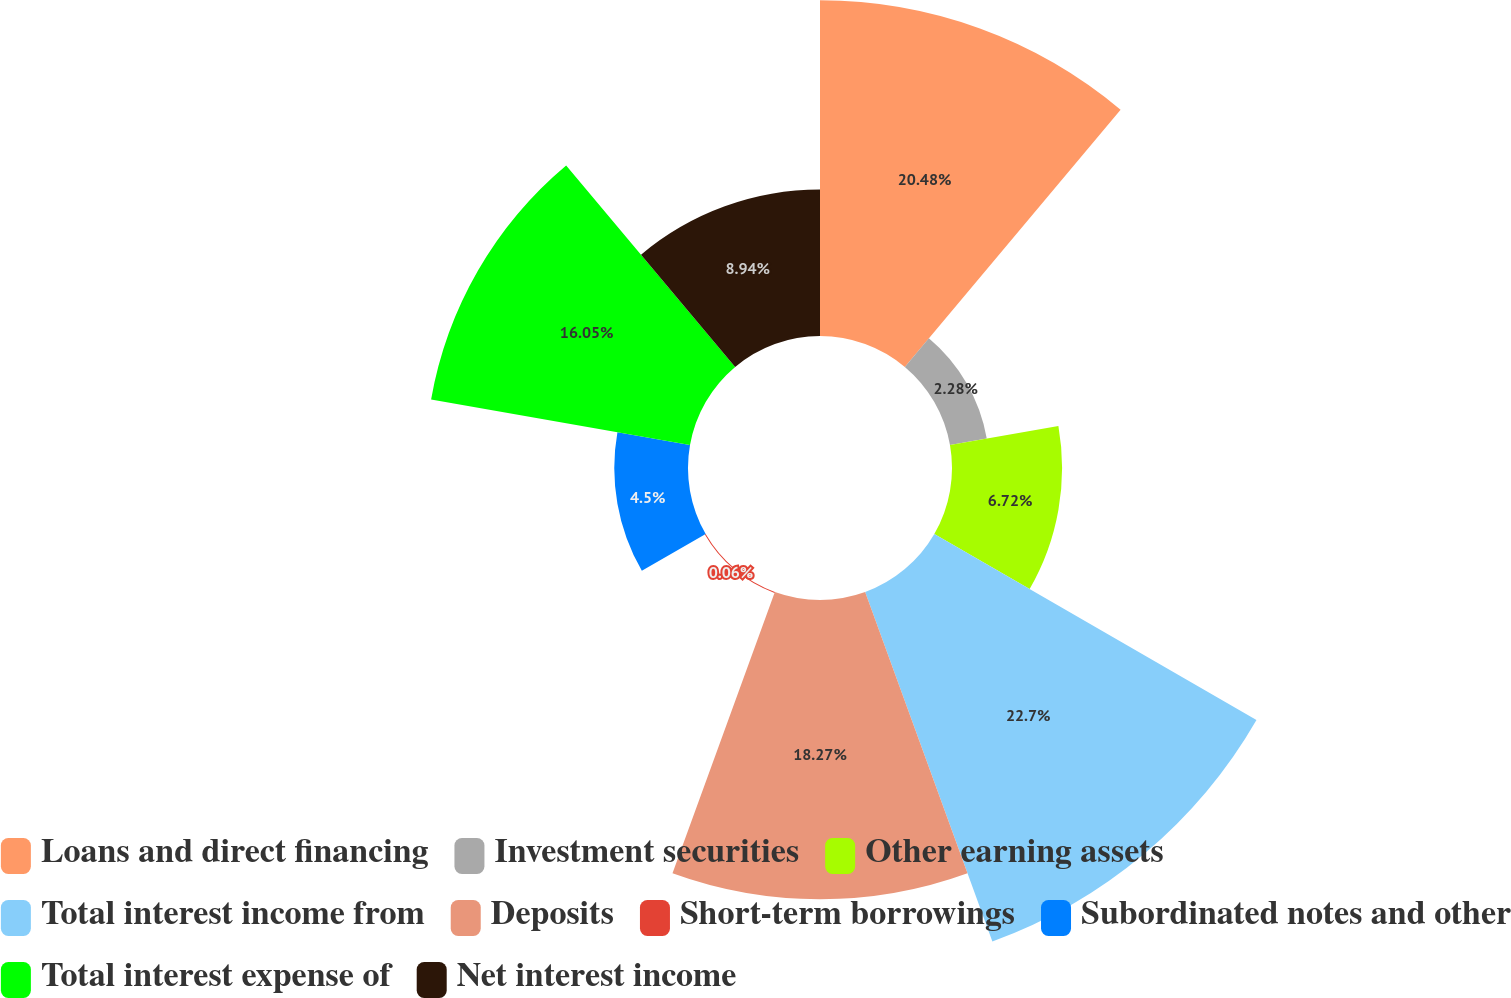Convert chart. <chart><loc_0><loc_0><loc_500><loc_500><pie_chart><fcel>Loans and direct financing<fcel>Investment securities<fcel>Other earning assets<fcel>Total interest income from<fcel>Deposits<fcel>Short-term borrowings<fcel>Subordinated notes and other<fcel>Total interest expense of<fcel>Net interest income<nl><fcel>20.49%<fcel>2.28%<fcel>6.72%<fcel>22.71%<fcel>18.27%<fcel>0.06%<fcel>4.5%<fcel>16.05%<fcel>8.94%<nl></chart> 